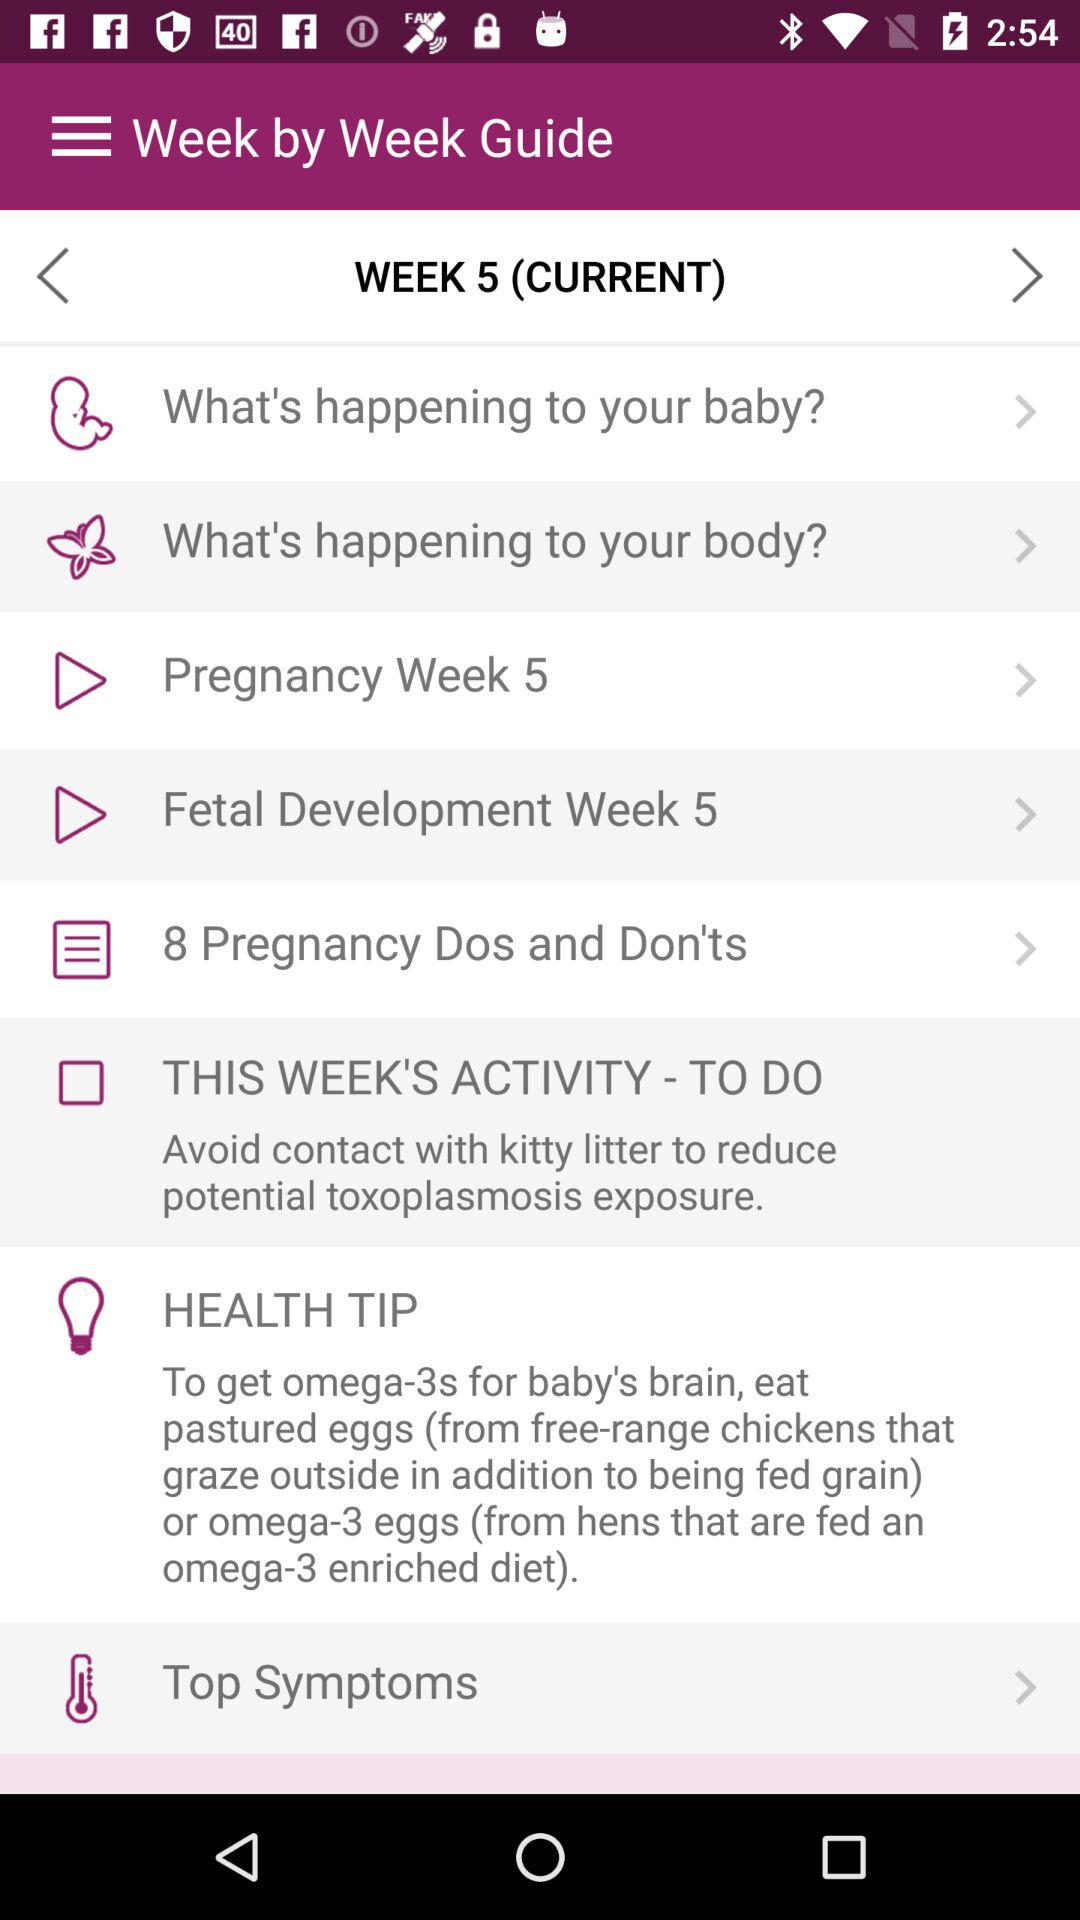What should I eat to get omega-3s for the baby's brain? You should eat "pastured eggs" or "omega-3 eggs" to get omega-3s for the baby's brain. 